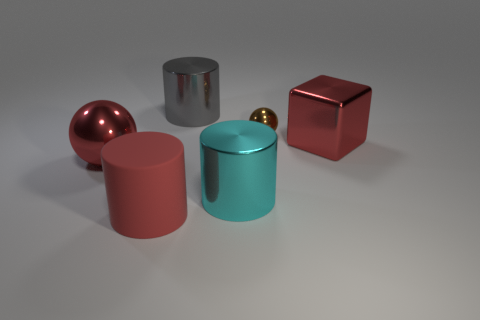Are there any other things that have the same size as the brown metallic ball?
Offer a terse response. No. The other shiny object that is the same shape as the brown object is what size?
Make the answer very short. Large. There is a shiny object that is in front of the large red metallic ball; is there a gray shiny cylinder behind it?
Keep it short and to the point. Yes. Do the large matte cylinder and the small metallic thing have the same color?
Your answer should be very brief. No. How many other things are the same shape as the tiny brown thing?
Make the answer very short. 1. Are there more large gray things that are left of the brown object than red metallic balls to the right of the large cyan metal cylinder?
Offer a very short reply. Yes. There is a red metallic object that is on the right side of the red matte object; is its size the same as the ball in front of the red cube?
Offer a very short reply. Yes. The big cyan metallic thing has what shape?
Offer a very short reply. Cylinder. What is the color of the large ball that is made of the same material as the red cube?
Offer a very short reply. Red. Do the large cube and the red thing that is in front of the large cyan metal cylinder have the same material?
Offer a terse response. No. 